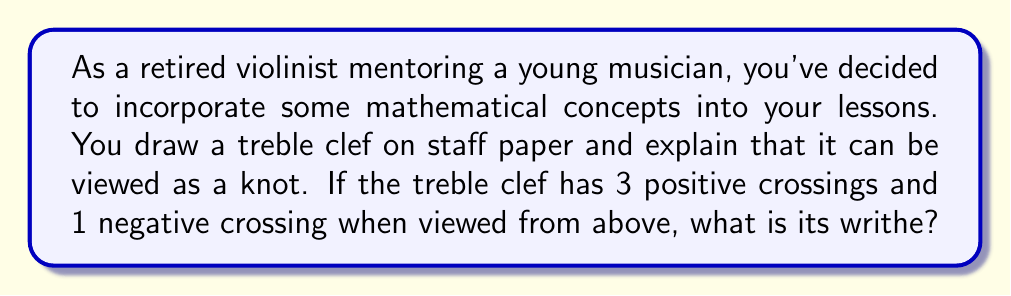Can you answer this question? To calculate the writhe of the treble clef knot, we need to follow these steps:

1. Understand the concept of writhe:
   The writhe of a knot is the sum of the signs of its crossings when viewed from above.

2. Identify the crossings:
   In this case, we're given that the treble clef has:
   - 3 positive crossings
   - 1 negative crossing

3. Assign values to the crossings:
   - Each positive crossing contributes +1 to the writhe
   - Each negative crossing contributes -1 to the writhe

4. Calculate the writhe:
   $$ \text{Writhe} = \sum_{i=1}^{n} \text{sign}(c_i) $$
   Where $c_i$ represents each crossing, and $n$ is the total number of crossings.

   In this case:
   $$ \text{Writhe} = (+1) + (+1) + (+1) + (-1) $$
   $$ \text{Writhe} = 3 + (-1) = 2 $$

Therefore, the writhe of the treble clef knot is 2.
Answer: 2 